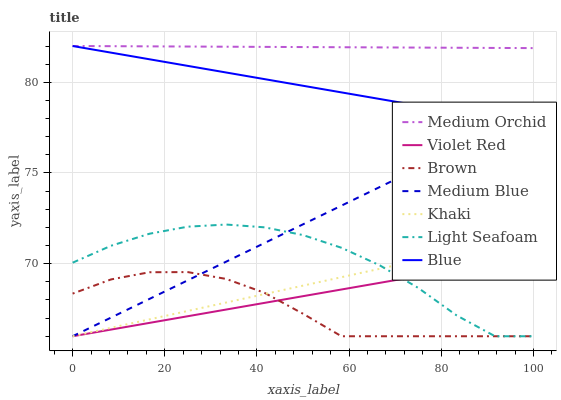Does Brown have the minimum area under the curve?
Answer yes or no. Yes. Does Medium Orchid have the maximum area under the curve?
Answer yes or no. Yes. Does Violet Red have the minimum area under the curve?
Answer yes or no. No. Does Violet Red have the maximum area under the curve?
Answer yes or no. No. Is Violet Red the smoothest?
Answer yes or no. Yes. Is Light Seafoam the roughest?
Answer yes or no. Yes. Is Brown the smoothest?
Answer yes or no. No. Is Brown the roughest?
Answer yes or no. No. Does Brown have the lowest value?
Answer yes or no. Yes. Does Medium Orchid have the lowest value?
Answer yes or no. No. Does Medium Orchid have the highest value?
Answer yes or no. Yes. Does Violet Red have the highest value?
Answer yes or no. No. Is Khaki less than Medium Orchid?
Answer yes or no. Yes. Is Blue greater than Brown?
Answer yes or no. Yes. Does Medium Blue intersect Light Seafoam?
Answer yes or no. Yes. Is Medium Blue less than Light Seafoam?
Answer yes or no. No. Is Medium Blue greater than Light Seafoam?
Answer yes or no. No. Does Khaki intersect Medium Orchid?
Answer yes or no. No. 